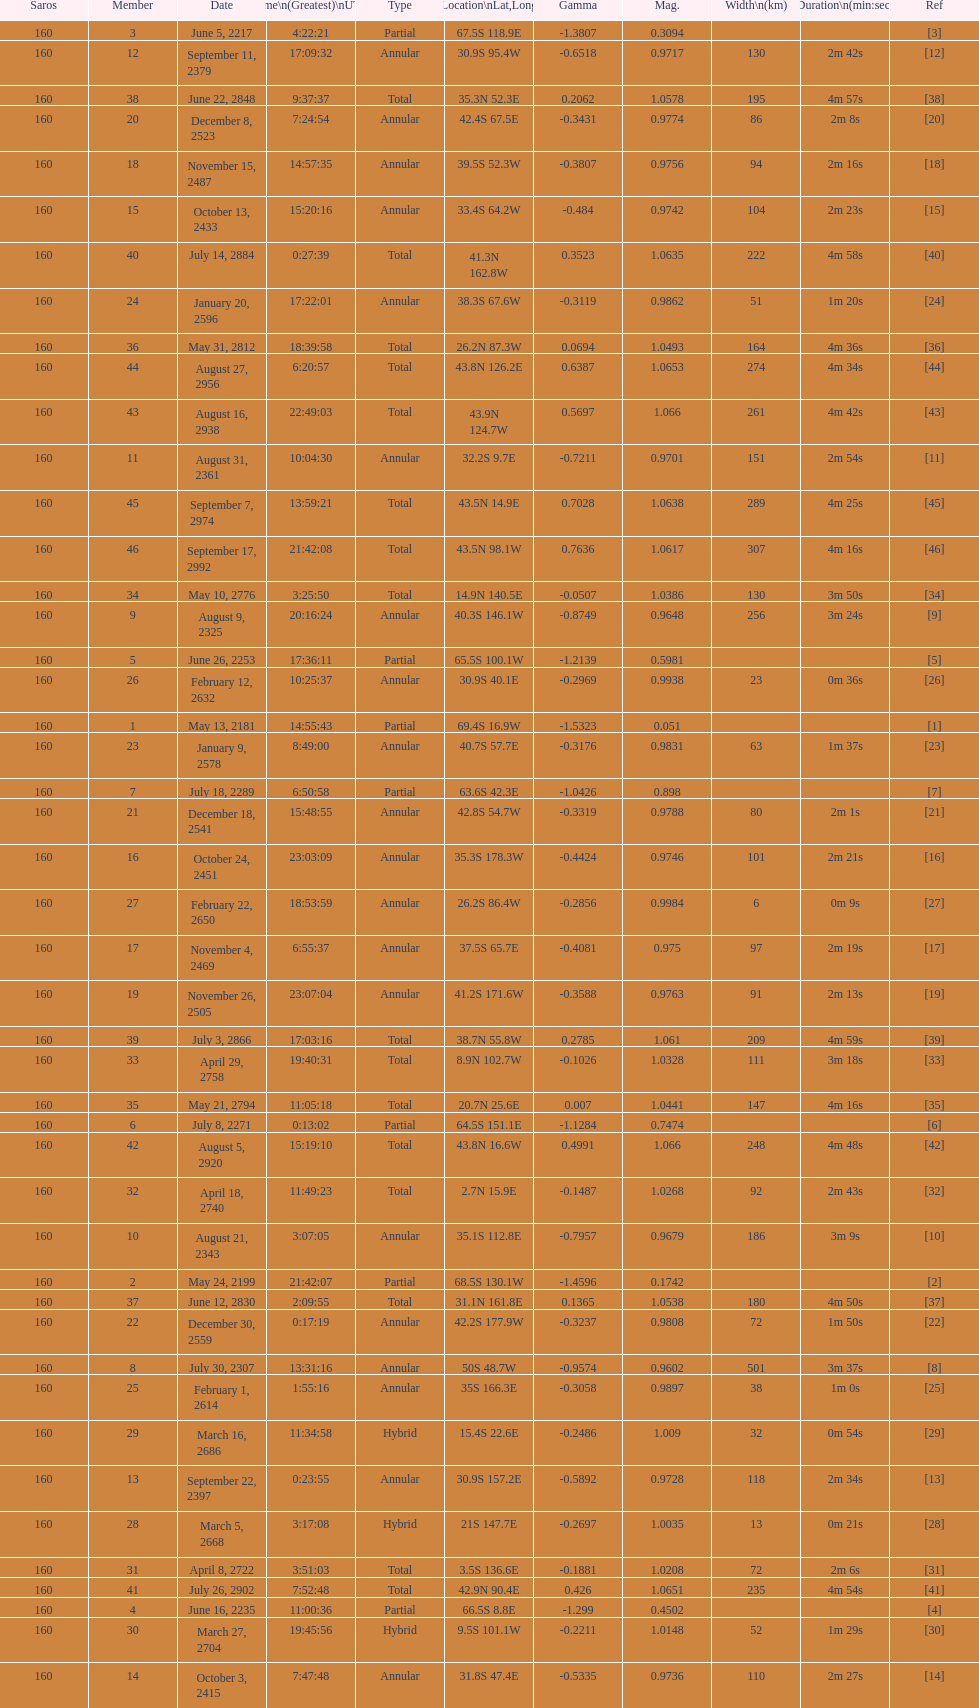Which one has a greater breadth, 8 or 21? 8. 